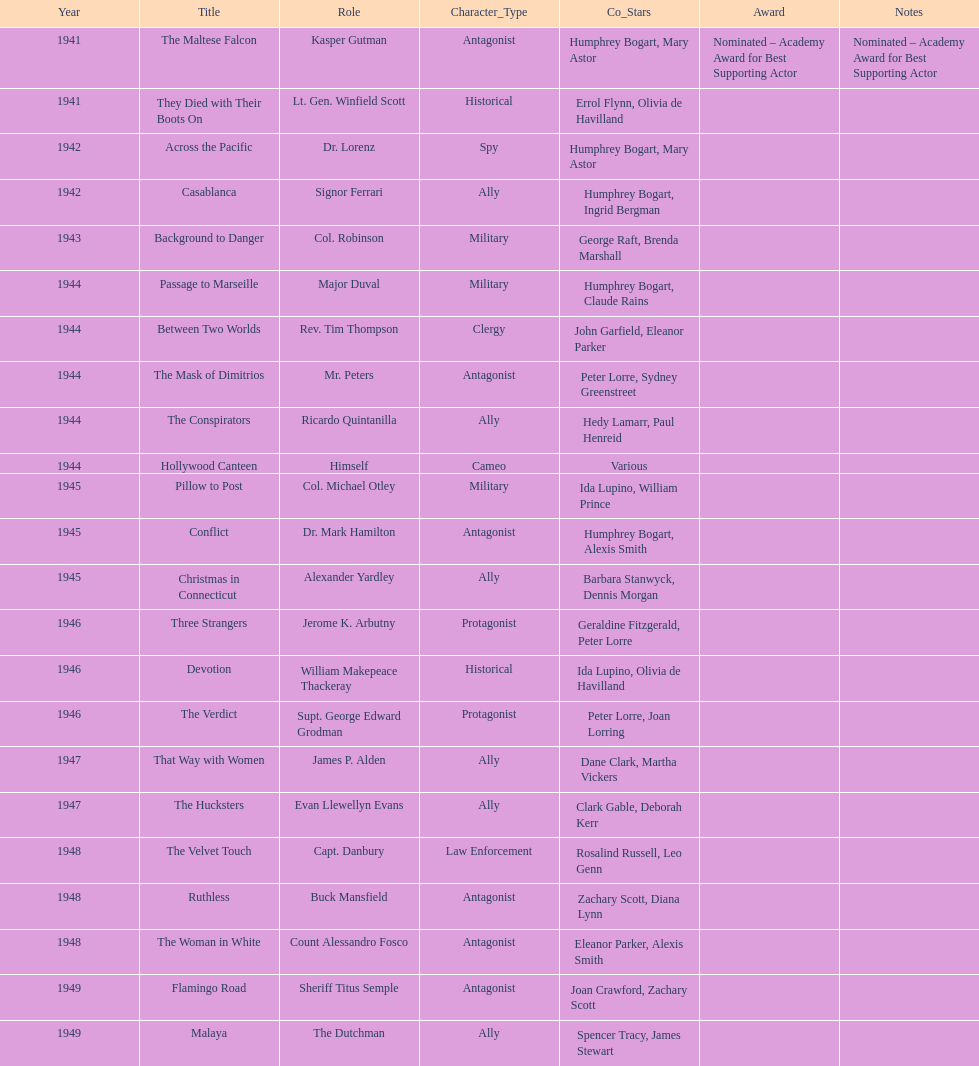How long did sydney greenstreet's acting career last? 9 years. 